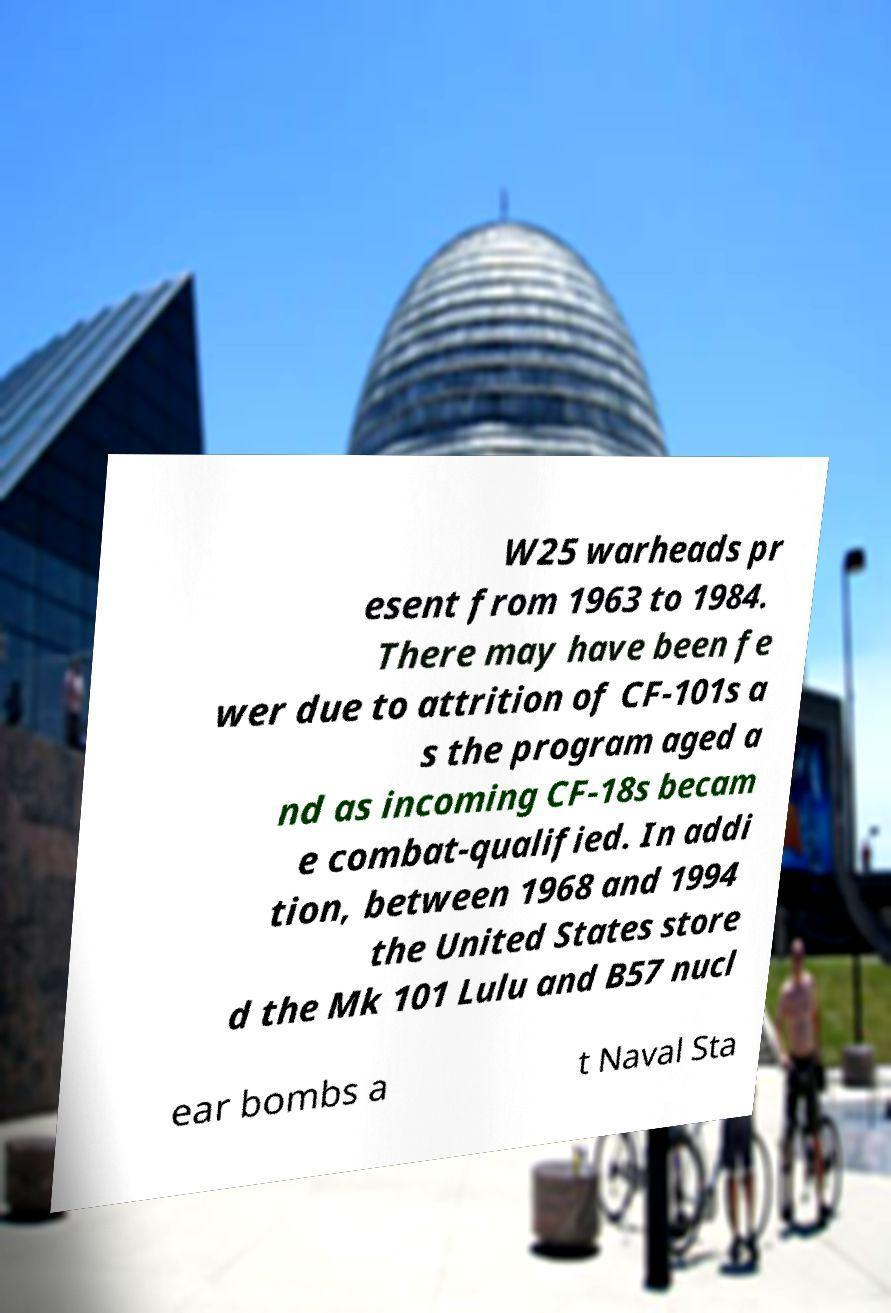Could you extract and type out the text from this image? W25 warheads pr esent from 1963 to 1984. There may have been fe wer due to attrition of CF-101s a s the program aged a nd as incoming CF-18s becam e combat-qualified. In addi tion, between 1968 and 1994 the United States store d the Mk 101 Lulu and B57 nucl ear bombs a t Naval Sta 